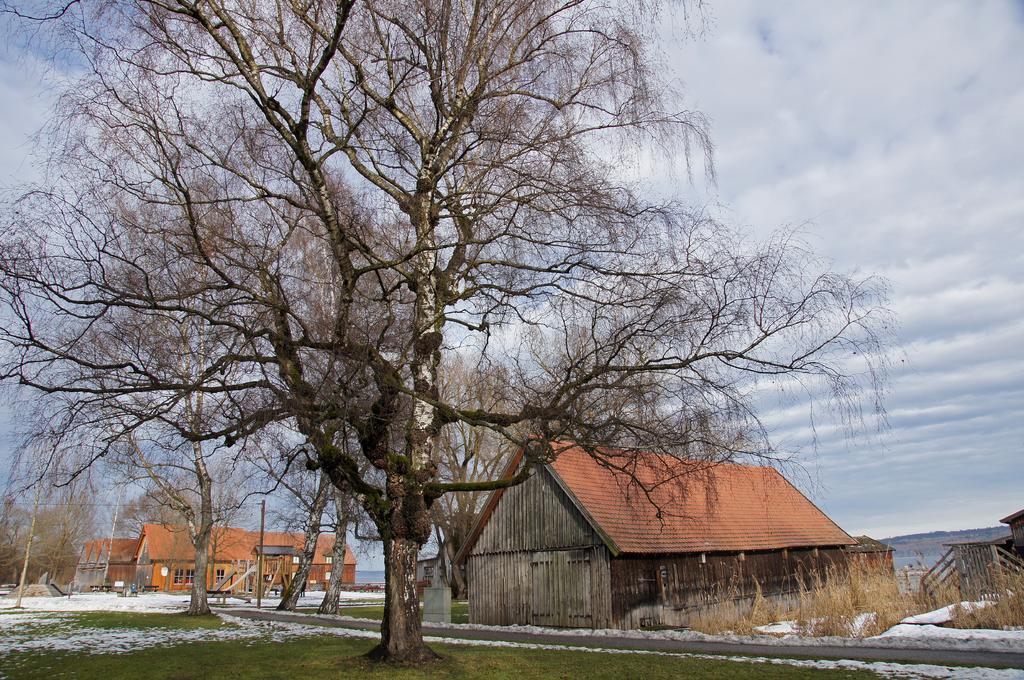Please provide a concise description of this image. In the picture I can see trees, buildings, the grass and plants. In the background I can see trees, the sky and some other objects on the ground. 